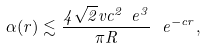Convert formula to latex. <formula><loc_0><loc_0><loc_500><loc_500>\alpha ( r ) \lesssim \frac { 4 \sqrt { 2 } v c ^ { 2 } \ e ^ { 3 } } { \pi R } \, \ e ^ { - c r } ,</formula> 